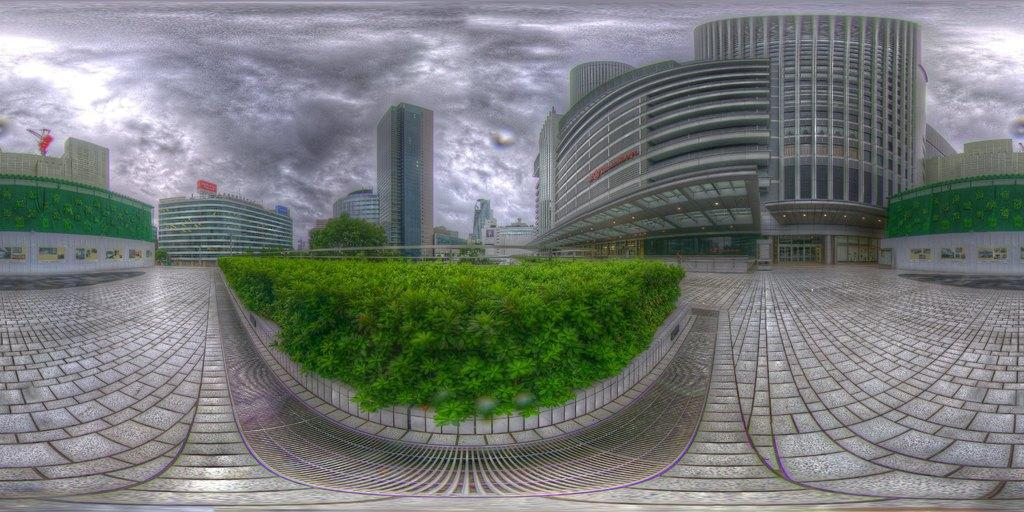What type of structures can be seen in the image? There are many buildings in the image. What is the purpose of the footpath in the image? The footpath in the image is likely for pedestrians to walk on. What type of vegetation is present in the image? There is grass in the image. What part of a building can be seen in the image? There is a window of a building in the image. How would you describe the weather based on the sky in the image? The sky is gray and cloudy in the image, suggesting overcast or potentially rainy weather. What type of plants can be seen growing inside the building window in the image? There are no plants visible inside the building window in the image. What type of jewel is embedded in the grass in the image? There is no jewel present in the grass in the image. 